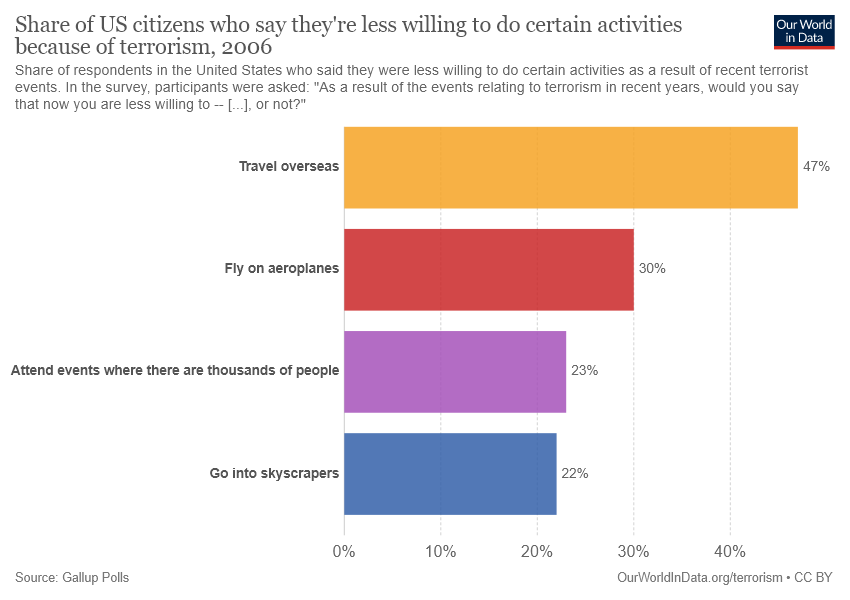Outline some significant characteristics in this image. I need help finding the value of a yellow bar that is 47.. The difference between the largest and smallest bar is 25. 